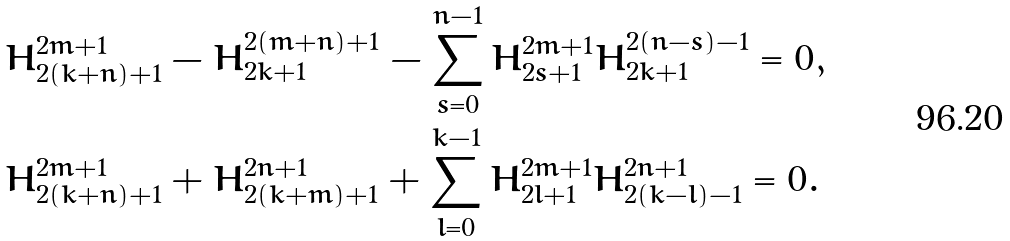<formula> <loc_0><loc_0><loc_500><loc_500>& H ^ { 2 m + 1 } _ { 2 ( k + n ) + 1 } - H ^ { 2 ( m + n ) + 1 } _ { 2 k + 1 } - \sum _ { s = 0 } ^ { n - 1 } H ^ { 2 m + 1 } _ { 2 s + 1 } H ^ { 2 ( n - s ) - 1 } _ { 2 k + 1 } = 0 , \\ & H ^ { 2 m + 1 } _ { 2 ( k + n ) + 1 } + H ^ { 2 n + 1 } _ { 2 ( k + m ) + 1 } + \sum _ { l = 0 } ^ { k - 1 } H ^ { 2 m + 1 } _ { 2 l + 1 } H ^ { 2 n + 1 } _ { 2 ( k - l ) - 1 } = 0 .</formula> 